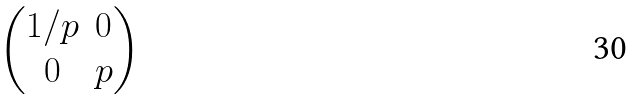Convert formula to latex. <formula><loc_0><loc_0><loc_500><loc_500>\begin{pmatrix} 1 / p & 0 \\ 0 & p \\ \end{pmatrix}</formula> 